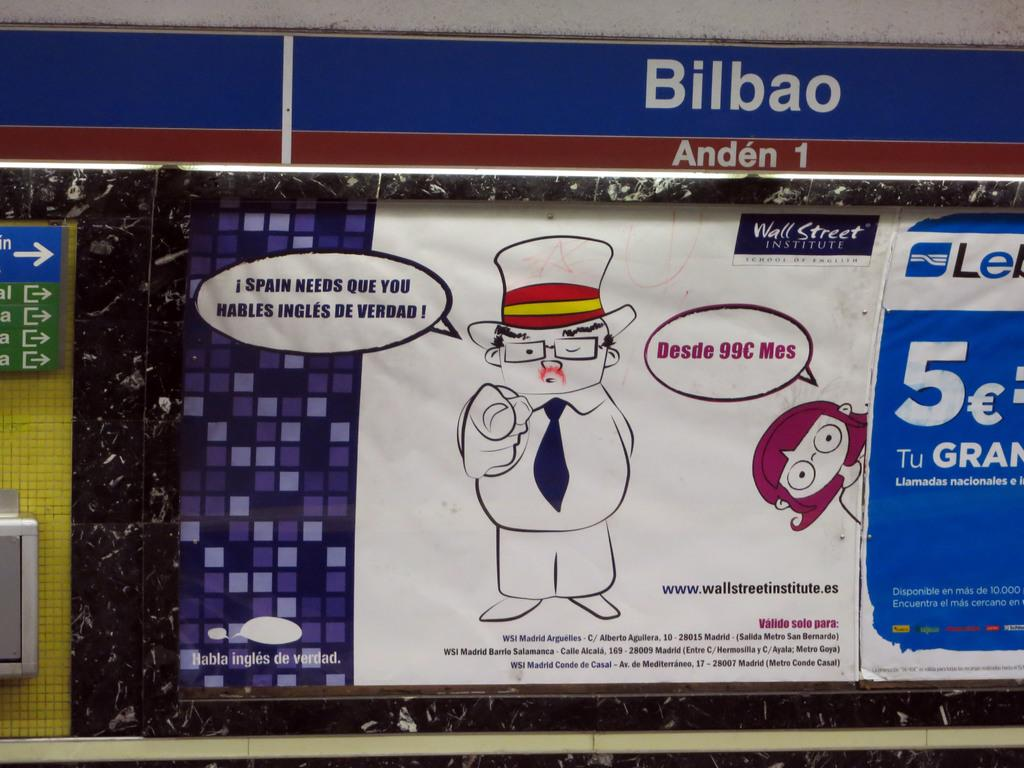What objects are present in the image that are made of boards? There are boards in the image, but the specific objects made of boards are not mentioned. What is attached to the boards in the image? There is a poster attached to the boards in the image. What can be found on the poster? The poster contains images, words, and numbers. How many men are shown on the map in the image? There is no map present in the image, so it is not possible to answer that question. 